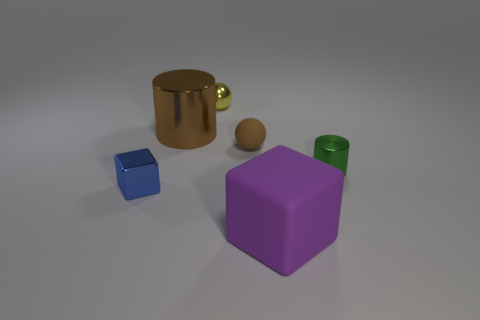Add 2 tiny things. How many objects exist? 8 Subtract all cylinders. How many objects are left? 4 Subtract 1 cylinders. How many cylinders are left? 1 Subtract all green metal cylinders. Subtract all rubber objects. How many objects are left? 3 Add 3 big shiny cylinders. How many big shiny cylinders are left? 4 Add 6 cubes. How many cubes exist? 8 Subtract 0 blue balls. How many objects are left? 6 Subtract all yellow cylinders. Subtract all blue blocks. How many cylinders are left? 2 Subtract all green cylinders. How many blue balls are left? 0 